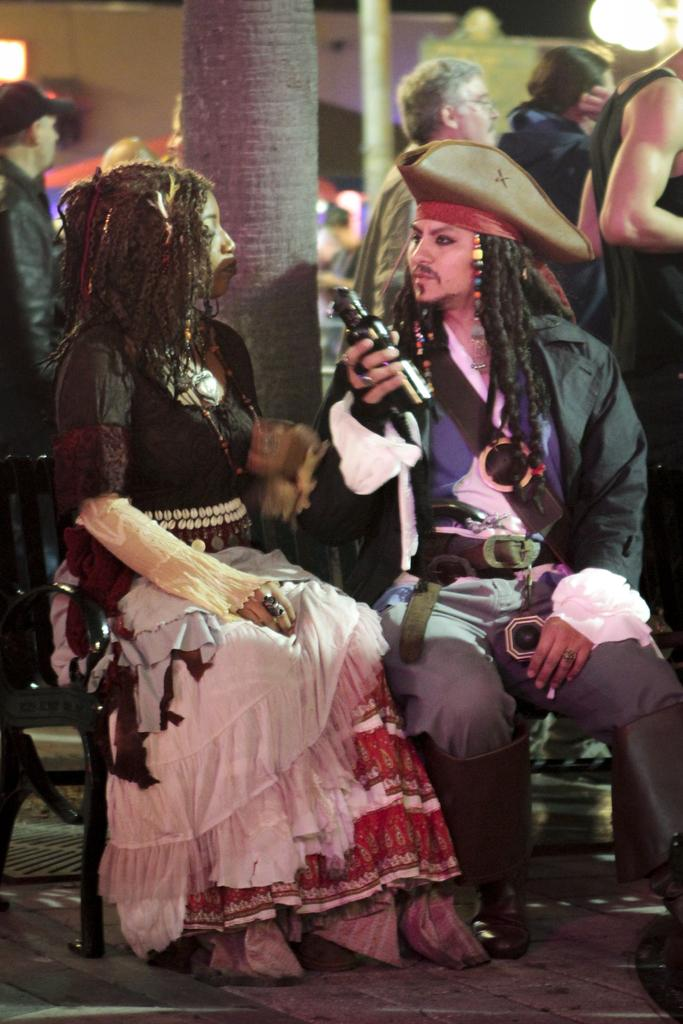Who are the people in the image? There is a man and a woman in the image. What are they doing in the image? They are sitting on chairs. What are they wearing in the image? They are wearing fancy dresses. What can be seen in the background of the image? There appears to be a tree trunk in the image. What else can be observed about the people in the image? There are people standing in the image, and a man is holding an object in his hand. What type of harmony is being played by the daughter in the image? There is no daughter present in the image, and no music or harmony is being played. What kind of bait is being used by the people in the image? There is no indication of fishing or bait in the image; it features a man and a woman sitting on chairs, wearing fancy dresses, and surrounded by other people. 